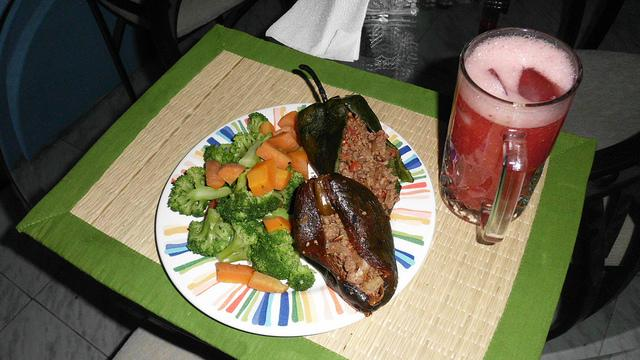What type of drink is in the cup? soda 